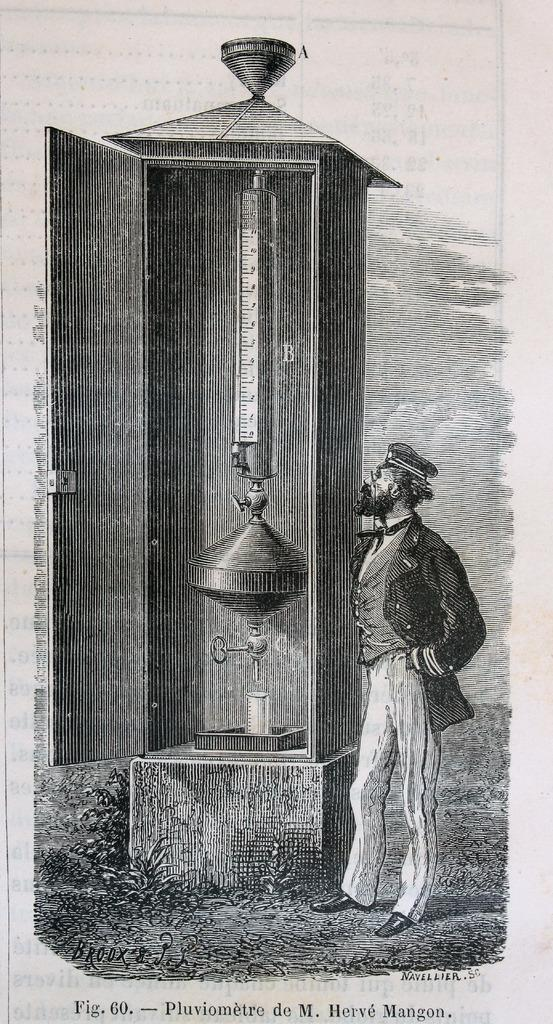What is depicted on the paper in the image? The paper contains a cartoon image of a man. Are there any objects or items included in the cartoon image? Yes, the cartoon image includes a wooden box. Can you describe any additional features of the paper? There is a watermark on the bottom of the paper. How many frogs are riding bikes in the image? There are no frogs or bikes present in the image. 